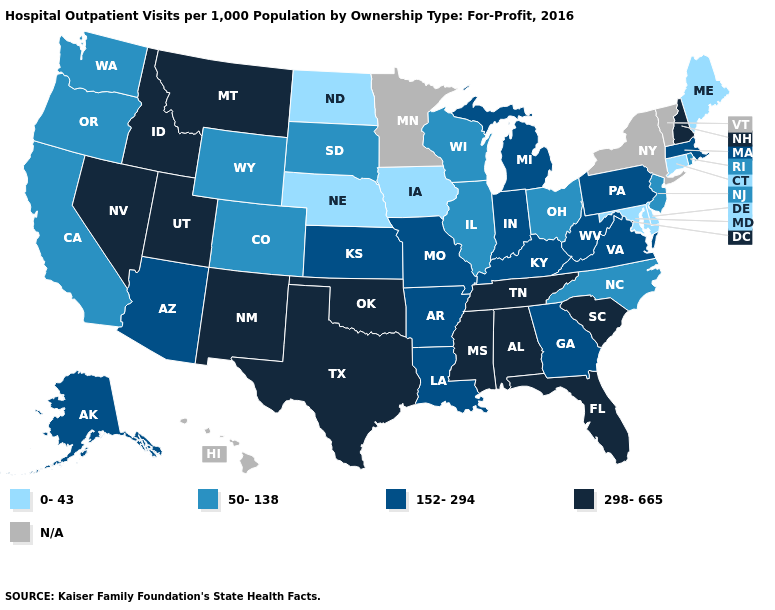What is the value of Arkansas?
Be succinct. 152-294. Which states hav the highest value in the West?
Be succinct. Idaho, Montana, Nevada, New Mexico, Utah. What is the lowest value in the MidWest?
Short answer required. 0-43. Is the legend a continuous bar?
Short answer required. No. Among the states that border Connecticut , does Rhode Island have the lowest value?
Give a very brief answer. Yes. Which states have the lowest value in the South?
Write a very short answer. Delaware, Maryland. What is the lowest value in states that border Nevada?
Quick response, please. 50-138. Name the states that have a value in the range 50-138?
Concise answer only. California, Colorado, Illinois, New Jersey, North Carolina, Ohio, Oregon, Rhode Island, South Dakota, Washington, Wisconsin, Wyoming. Name the states that have a value in the range N/A?
Short answer required. Hawaii, Minnesota, New York, Vermont. Which states have the highest value in the USA?
Write a very short answer. Alabama, Florida, Idaho, Mississippi, Montana, Nevada, New Hampshire, New Mexico, Oklahoma, South Carolina, Tennessee, Texas, Utah. What is the value of Virginia?
Short answer required. 152-294. What is the lowest value in states that border Illinois?
Give a very brief answer. 0-43. Is the legend a continuous bar?
Short answer required. No. What is the value of North Carolina?
Answer briefly. 50-138. 